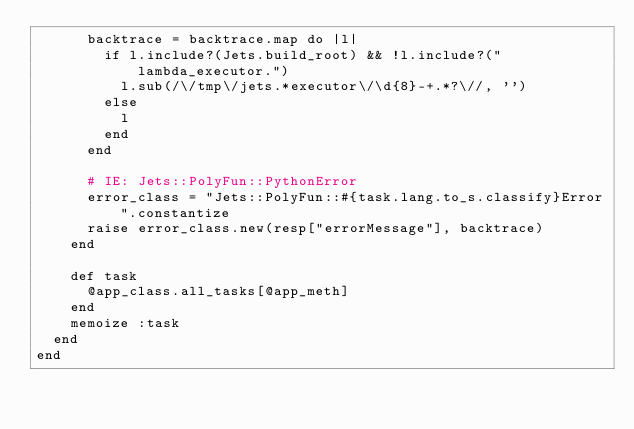<code> <loc_0><loc_0><loc_500><loc_500><_Ruby_>      backtrace = backtrace.map do |l|
        if l.include?(Jets.build_root) && !l.include?("lambda_executor.")
          l.sub(/\/tmp\/jets.*executor\/\d{8}-+.*?\//, '')
        else
          l
        end
      end

      # IE: Jets::PolyFun::PythonError
      error_class = "Jets::PolyFun::#{task.lang.to_s.classify}Error".constantize
      raise error_class.new(resp["errorMessage"], backtrace)
    end

    def task
      @app_class.all_tasks[@app_meth]
    end
    memoize :task
  end
end
</code> 